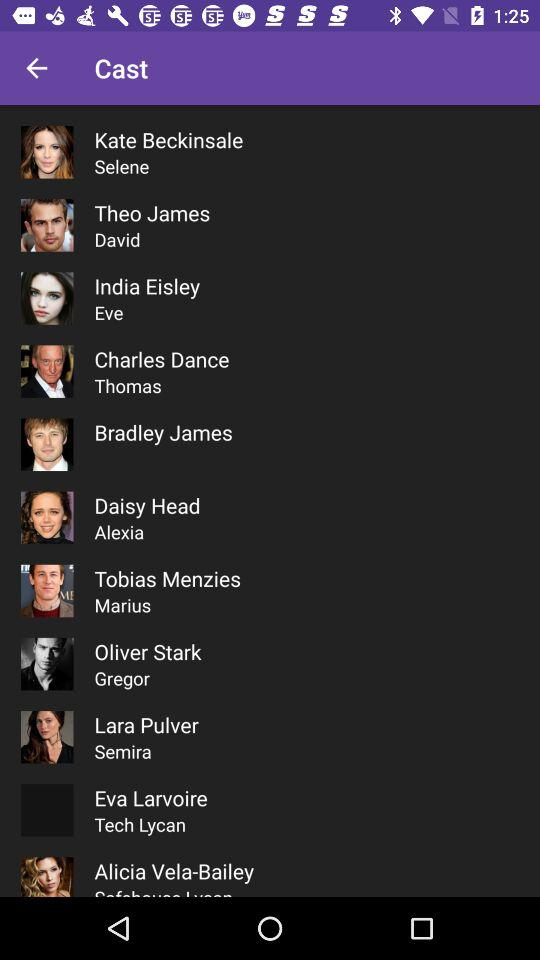Who played the role of Eve? The role of Eve was played by India Eisley. 